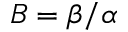Convert formula to latex. <formula><loc_0><loc_0><loc_500><loc_500>B = \beta / \alpha</formula> 